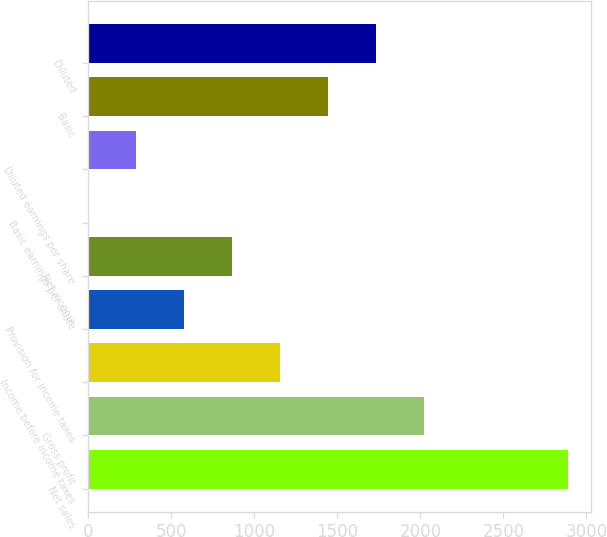Convert chart to OTSL. <chart><loc_0><loc_0><loc_500><loc_500><bar_chart><fcel>Net sales<fcel>Gross profit<fcel>Income before income taxes<fcel>Provision for income taxes<fcel>Net income<fcel>Basic earnings per share<fcel>Diluted earnings per share<fcel>Basic<fcel>Diluted<nl><fcel>2886<fcel>2020.25<fcel>1154.51<fcel>577.35<fcel>865.93<fcel>0.19<fcel>288.77<fcel>1443.09<fcel>1731.67<nl></chart> 